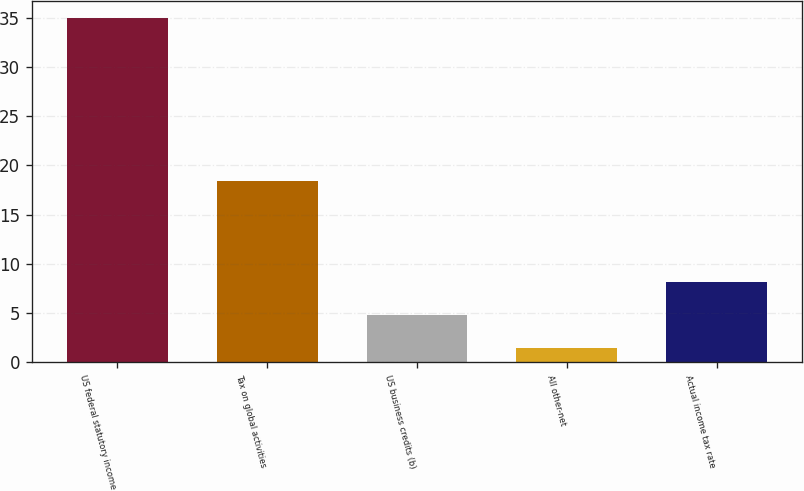Convert chart to OTSL. <chart><loc_0><loc_0><loc_500><loc_500><bar_chart><fcel>US federal statutory income<fcel>Tax on global activities<fcel>US business credits (b)<fcel>All other-net<fcel>Actual income tax rate<nl><fcel>35<fcel>18.4<fcel>4.85<fcel>1.5<fcel>8.2<nl></chart> 